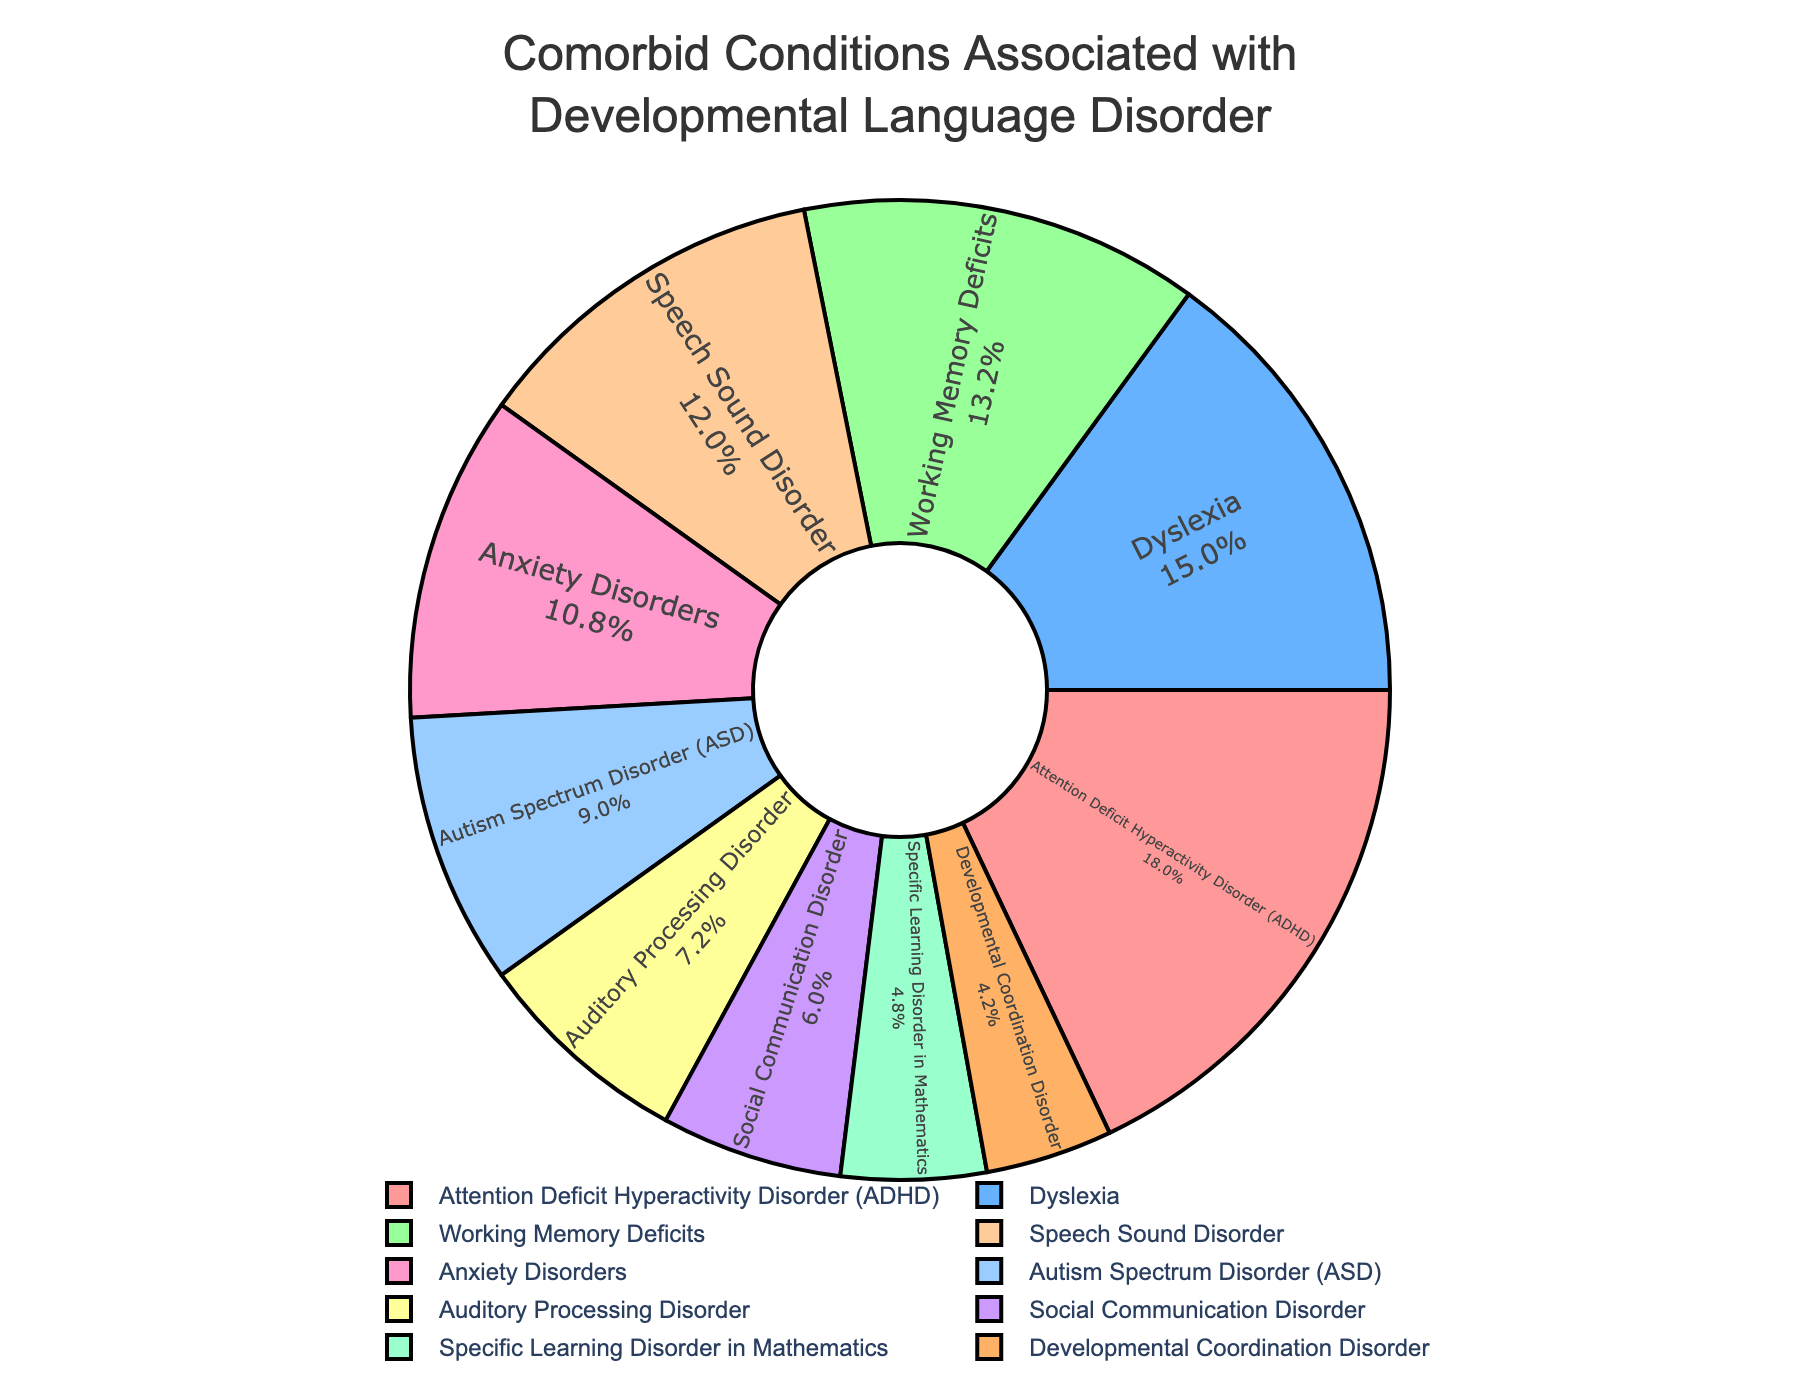What's the condition with the highest percentage? The condition with the highest percentage can be seen by identifying the largest segment of the pie chart. The largest segment represents Attention Deficit Hyperactivity Disorder (ADHD), which occupies 30% of the chart.
Answer: Attention Deficit Hyperactivity Disorder (ADHD) Which condition has a higher percentage, Autism Spectrum Disorder (ASD) or Dyslexia? To answer this question, we compare the percentages of both conditions from the chart. Dyslexia has 25% and Autism Spectrum Disorder (ASD) has 15%. Since 25% (Dyslexia) is greater than 15% (ASD), Dyslexia has a higher percentage.
Answer: Dyslexia What is the sum of percentages for Speech Sound Disorder and Working Memory Deficits? To find the sum, we add the percentage of Speech Sound Disorder (20%) and Working Memory Deficits (22%). The total percentage is 20% + 22% = 42%.
Answer: 42% How much greater is the percentage of Anxiety Disorders compared to Specific Learning Disorder in Mathematics? The percentage of Anxiety Disorders is 18%, while Specific Learning Disorder in Mathematics is 8%. To find the difference, we subtract 8% from 18%, which gives 10%.
Answer: 10% What percentage of the pie chart is represented by conditions that have less than 10% each? We identify the conditions with less than 10% each: Specific Learning Disorder in Mathematics (8%) and Developmental Coordination Disorder (7%). Adding these percentages gives 8% + 7% = 15%.
Answer: 15% Which comorbid condition is represented in green? By referring to the custom color palette used in the figure, we note that the condition represented in green is the one associated with the third color in the palette sequence. Dyslexia, with a 25% share, is likely represented in green based on the position in the legend.
Answer: Dyslexia What is the average percentage of Autism Spectrum Disorder, Anxiety Disorders, and Auditory Processing Disorder? To find the average percentage, we first sum the percentages of Autism Spectrum Disorder (15%), Anxiety Disorders (18%), and Auditory Processing Disorder (12%). The sum is 15% + 18% + 12% = 45%. Then, we divide by 3, giving us 45% / 3 = 15%.
Answer: 15% Which conditions have a percentage greater than 20%? By checking the pie chart, the conditions with percentages greater than 20% are Attention Deficit Hyperactivity Disorder (30%), Dyslexia (25%), and Working Memory Deficits (22%).
Answer: Attention Deficit Hyperactivity Disorder, Dyslexia, Working Memory Deficits What is the difference between the highest and lowest percentages in the chart? The highest percentage is for Attention Deficit Hyperactivity Disorder (30%), and the lowest is for Developmental Coordination Disorder (7%). The difference is calculated as 30% - 7% = 23%.
Answer: 23% What percentage do the conditions associated with communication difficulties (Autism Spectrum Disorder and Social Communication Disorder) total up to? Autism Spectrum Disorder has a percentage of 15%, and Social Communication Disorder has 10%. Adding these together, we get 15% + 10% = 25%.
Answer: 25% 